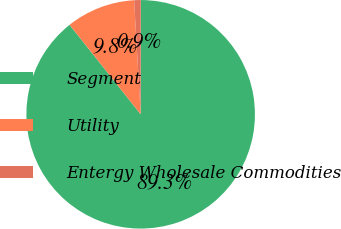Convert chart to OTSL. <chart><loc_0><loc_0><loc_500><loc_500><pie_chart><fcel>Segment<fcel>Utility<fcel>Entergy Wholesale Commodities<nl><fcel>89.3%<fcel>9.77%<fcel>0.93%<nl></chart> 